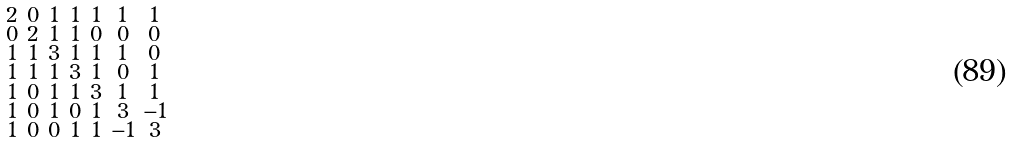<formula> <loc_0><loc_0><loc_500><loc_500>\begin{smallmatrix} 2 & 0 & 1 & 1 & 1 & 1 & 1 \\ 0 & 2 & 1 & 1 & 0 & 0 & 0 \\ 1 & 1 & 3 & 1 & 1 & 1 & 0 \\ 1 & 1 & 1 & 3 & 1 & 0 & 1 \\ 1 & 0 & 1 & 1 & 3 & 1 & 1 \\ 1 & 0 & 1 & 0 & 1 & 3 & - 1 \\ 1 & 0 & 0 & 1 & 1 & - 1 & 3 \end{smallmatrix}</formula> 